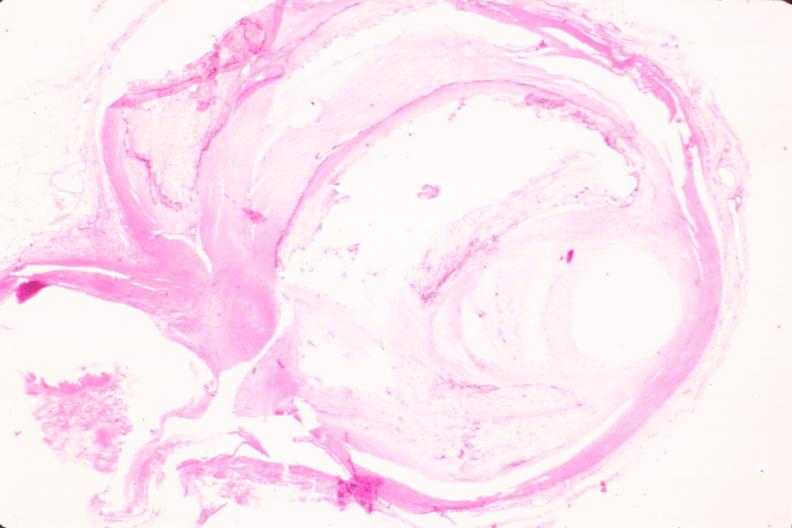what is present?
Answer the question using a single word or phrase. Vasculature 